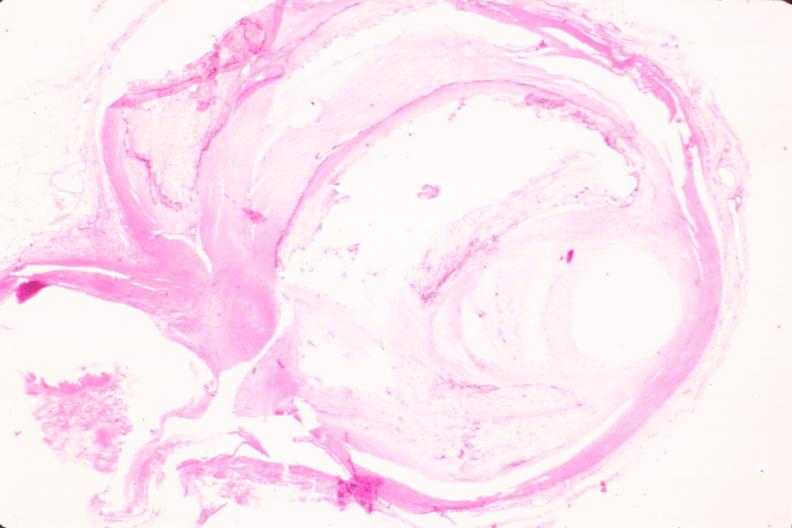what is present?
Answer the question using a single word or phrase. Vasculature 